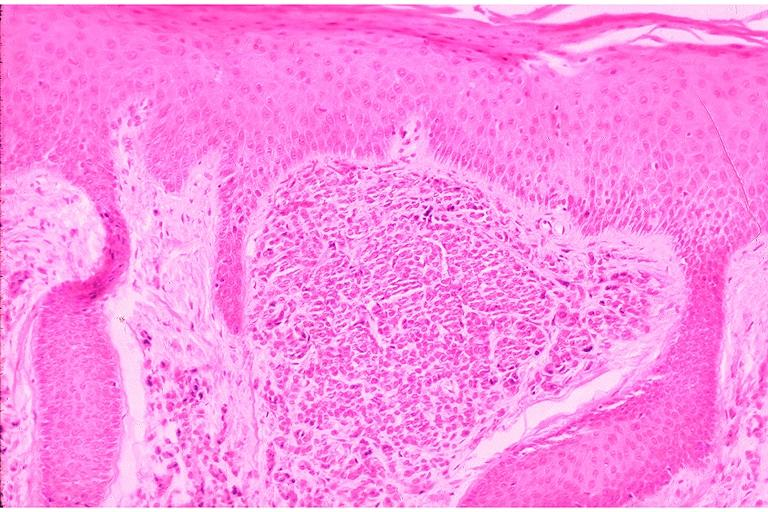does this image show intramucosal nevus?
Answer the question using a single word or phrase. Yes 